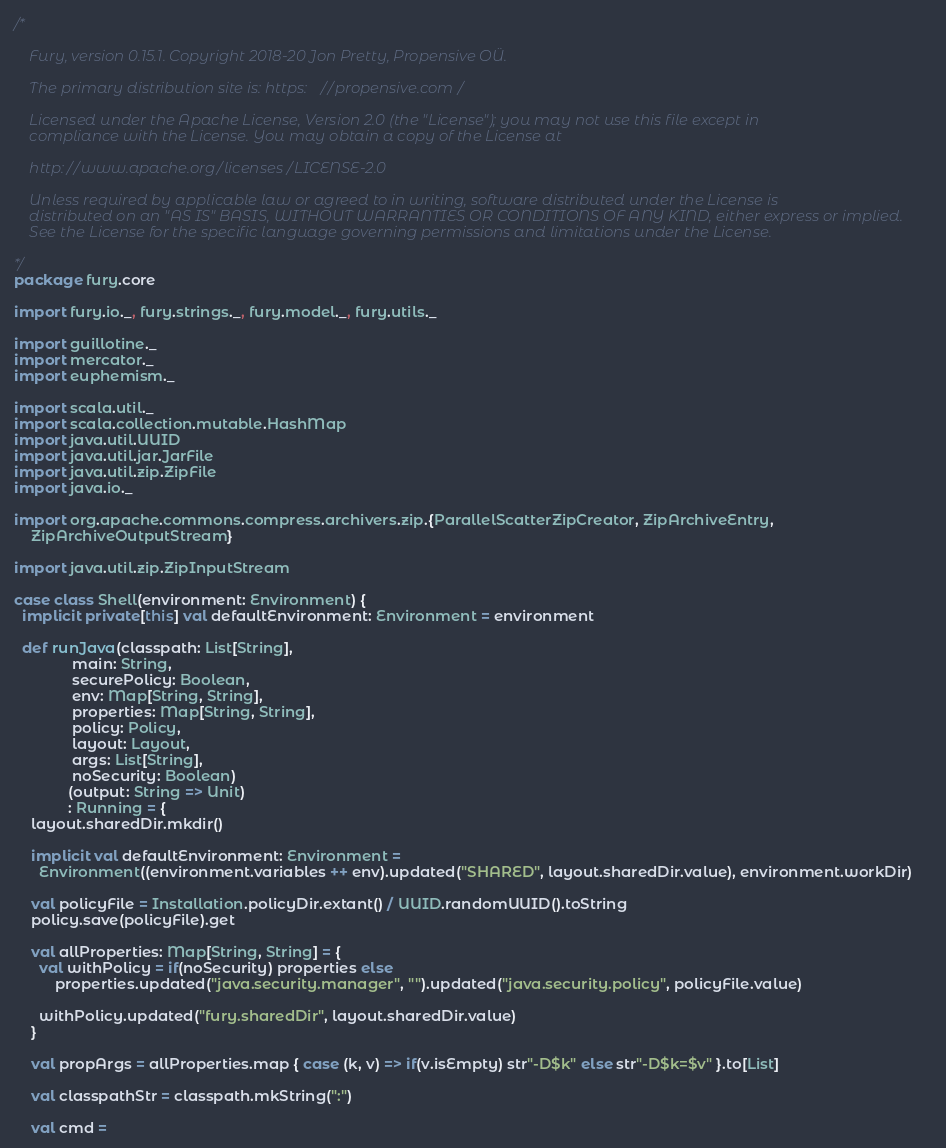Convert code to text. <code><loc_0><loc_0><loc_500><loc_500><_Scala_>/*

    Fury, version 0.15.1. Copyright 2018-20 Jon Pretty, Propensive OÜ.

    The primary distribution site is: https://propensive.com/

    Licensed under the Apache License, Version 2.0 (the "License"); you may not use this file except in
    compliance with the License. You may obtain a copy of the License at

    http://www.apache.org/licenses/LICENSE-2.0

    Unless required by applicable law or agreed to in writing, software distributed under the License is
    distributed on an "AS IS" BASIS, WITHOUT WARRANTIES OR CONDITIONS OF ANY KIND, either express or implied.
    See the License for the specific language governing permissions and limitations under the License.

*/
package fury.core

import fury.io._, fury.strings._, fury.model._, fury.utils._

import guillotine._
import mercator._
import euphemism._

import scala.util._
import scala.collection.mutable.HashMap
import java.util.UUID
import java.util.jar.JarFile
import java.util.zip.ZipFile
import java.io._

import org.apache.commons.compress.archivers.zip.{ParallelScatterZipCreator, ZipArchiveEntry,
    ZipArchiveOutputStream}

import java.util.zip.ZipInputStream

case class Shell(environment: Environment) {
  implicit private[this] val defaultEnvironment: Environment = environment

  def runJava(classpath: List[String],
              main: String,
              securePolicy: Boolean,
              env: Map[String, String],
              properties: Map[String, String],
              policy: Policy,
              layout: Layout,
              args: List[String],
              noSecurity: Boolean)
             (output: String => Unit)
             : Running = {
    layout.sharedDir.mkdir()

    implicit val defaultEnvironment: Environment =
      Environment((environment.variables ++ env).updated("SHARED", layout.sharedDir.value), environment.workDir)

    val policyFile = Installation.policyDir.extant() / UUID.randomUUID().toString
    policy.save(policyFile).get

    val allProperties: Map[String, String] = {
      val withPolicy = if(noSecurity) properties else
          properties.updated("java.security.manager", "").updated("java.security.policy", policyFile.value)
      
      withPolicy.updated("fury.sharedDir", layout.sharedDir.value)
    }

    val propArgs = allProperties.map { case (k, v) => if(v.isEmpty) str"-D$k" else str"-D$k=$v" }.to[List]

    val classpathStr = classpath.mkString(":")
    
    val cmd =</code> 